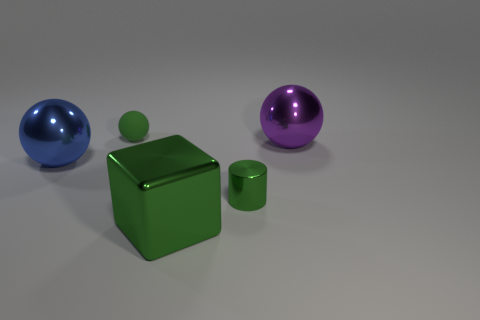There is a green object that is behind the small thing in front of the small green rubber thing; what is its shape?
Offer a terse response. Sphere. Are there any purple objects that have the same material as the tiny ball?
Make the answer very short. No. The metallic block that is the same color as the small cylinder is what size?
Give a very brief answer. Large. How many green things are either matte spheres or small metallic cubes?
Give a very brief answer. 1. Is there a thing of the same color as the small rubber sphere?
Your answer should be very brief. Yes. What size is the blue thing that is made of the same material as the green cylinder?
Offer a terse response. Large. How many balls are big green objects or green matte things?
Make the answer very short. 1. Are there more green matte balls than big green matte cubes?
Keep it short and to the point. Yes. What number of green things are the same size as the block?
Your answer should be compact. 0. What is the shape of the metal thing that is the same color as the large metal block?
Make the answer very short. Cylinder. 